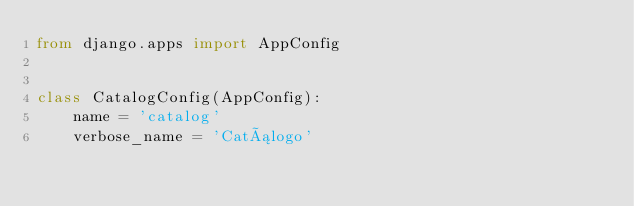Convert code to text. <code><loc_0><loc_0><loc_500><loc_500><_Python_>from django.apps import AppConfig


class CatalogConfig(AppConfig):
    name = 'catalog'
    verbose_name = 'Catálogo'
</code> 